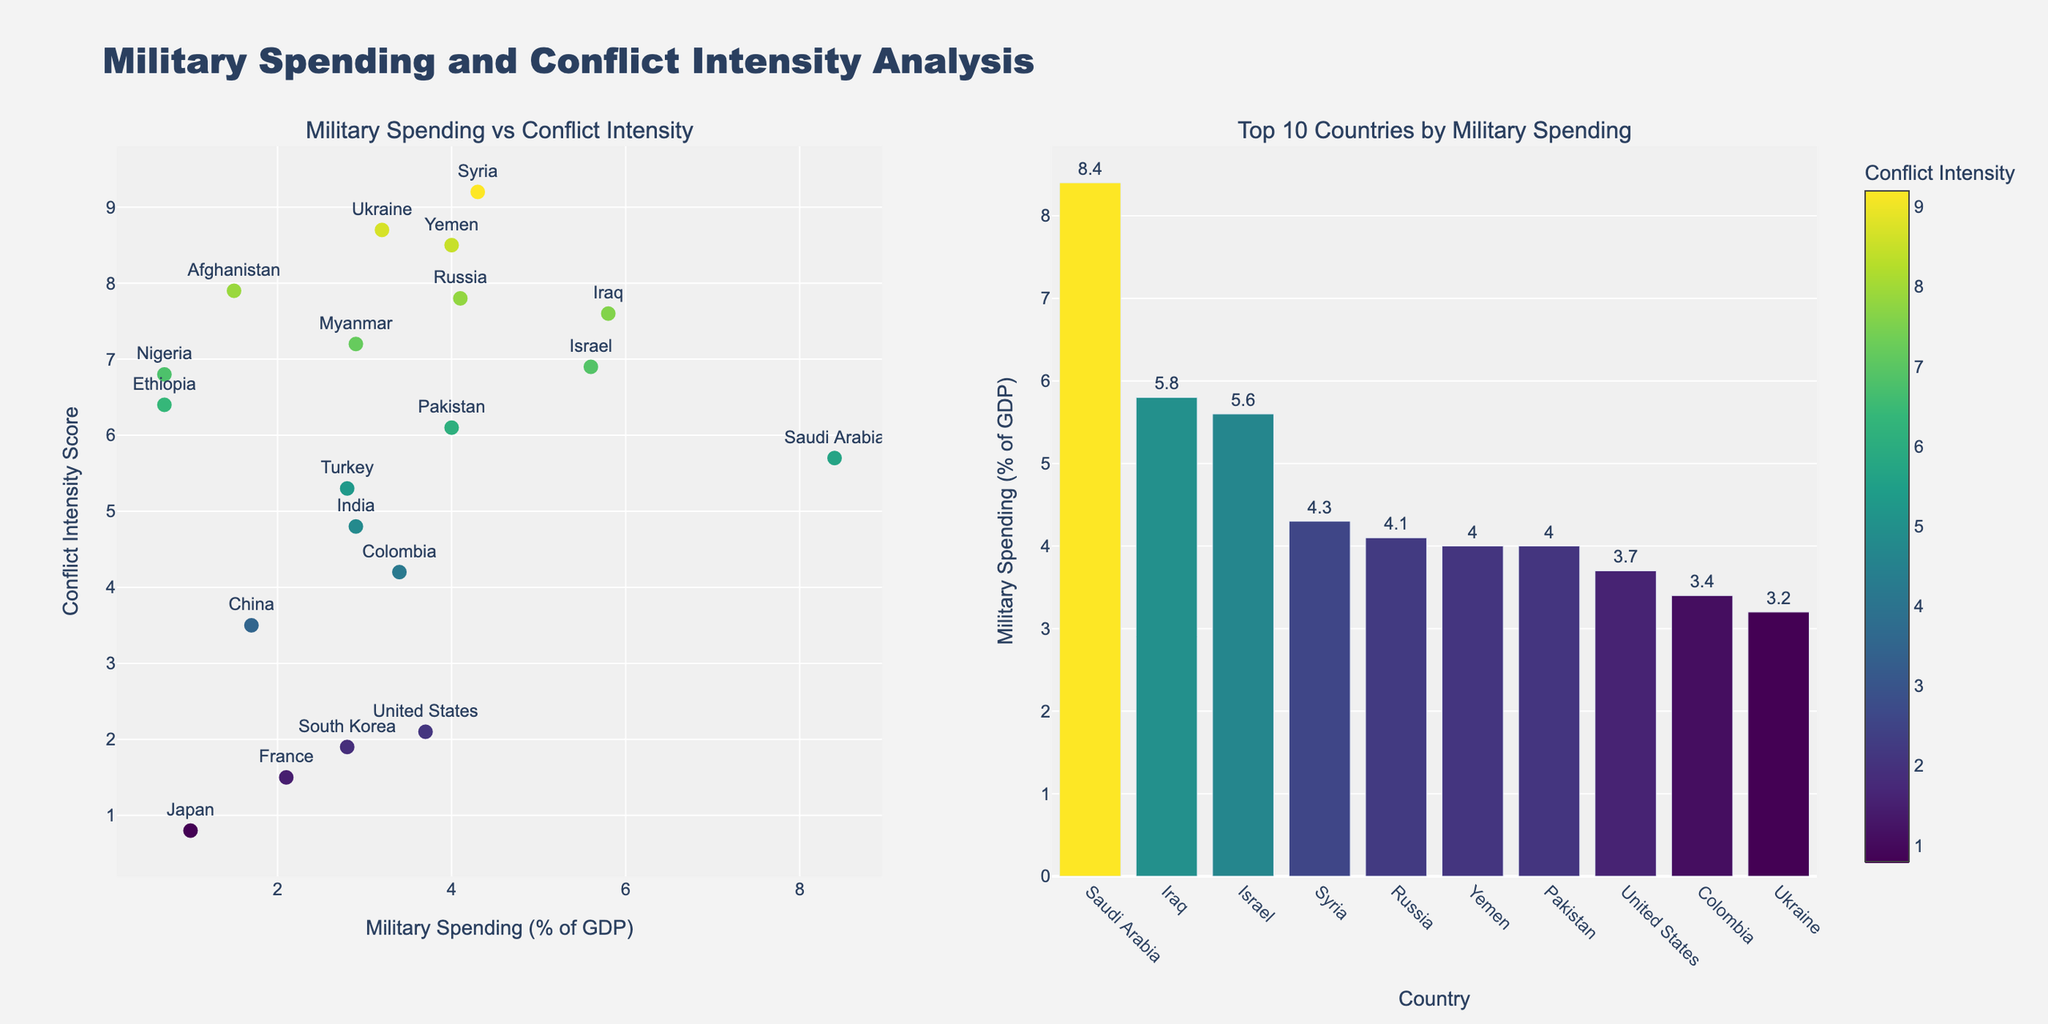How many countries have a military spending percentage of more than 4% of GDP? Count the countries in the scatter plot that have military spending above 4%, including Russia, Israel, Syria, Yemen, Pakistan, Iraq, and Saudi Arabia.
Answer: 7 Which country has the highest conflict intensity score, and what is it? Look at the scatter plot to identify the country with the highest y-value (Conflict Intensity Score). Syria has the highest score.
Answer: Syria, 9.2 What is the relationship between military spending and conflict intensity seen in the plot? Compare the overall trend in the scatter plot to determine if higher military spending is associated with higher conflict intensity.
Answer: Higher military spending tends to correlate with higher conflict intensity, but not always What is the average military spending percentage for the top 10 countries? Calculate the average military spending of the top 10 countries listed in the bar plot, summing their values and dividing by 10.
Answer: 4.1% Which countries have both low military spending and low conflict intensity? Identify countries in the scatter plot with both low on the x-axis (military spending) and y-axis (conflict intensity). Examples include Japan and South Korea.
Answer: Japan, South Korea How does Saudi Arabia's military spending compare to its conflict intensity score? Locate Saudi Arabia in the scatter plot or bar plot and compare its military spending percentage and conflict intensity score.
Answer: 8.4% military spending, 5.7 conflict intensity What is the difference between the conflict intensity scores of Russia and Ukraine? Compare the conflict intensity scores of Russia and Ukraine and find the difference between them.
Answer: 0.9 Which country in the top 10 by military spending has the lowest conflict intensity score, and what is that score? Look at the bar plot of the top 10 countries by military spending and find the one with the lowest y-value in terms of conflict intensity score.
Answer: United States, 2.1 Is there a strong correlation between military spending and conflict intensity for countries with spending above 5%? Examine high military spending countries (above 5%) in the scatter plot and assess if their conflict intensity scores are consistently high. Countries include Israel, Syria, Iraq, and Saudi Arabia. They all have high conflict intensity, suggesting a strong correlation in this subset.
Answer: Yes How does France's military spending compare to its conflict intensity? Locate France in the scatter plot and observe its x-value for military spending and y-value for conflict intensity.
Answer: 2.1% spending, 1.5 conflict intensity 